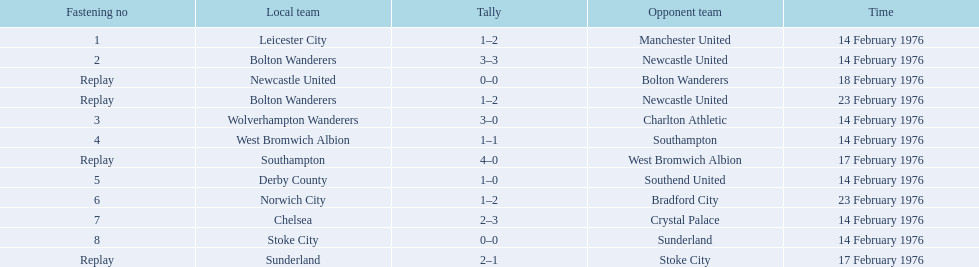Who were all of the teams? Leicester City, Manchester United, Bolton Wanderers, Newcastle United, Newcastle United, Bolton Wanderers, Bolton Wanderers, Newcastle United, Wolverhampton Wanderers, Charlton Athletic, West Bromwich Albion, Southampton, Southampton, West Bromwich Albion, Derby County, Southend United, Norwich City, Bradford City, Chelsea, Crystal Palace, Stoke City, Sunderland, Sunderland, Stoke City. And what were their scores? 1–2, 3–3, 0–0, 1–2, 3–0, 1–1, 4–0, 1–0, 1–2, 2–3, 0–0, 2–1. Between manchester and wolverhampton, who scored more? Wolverhampton Wanderers. 